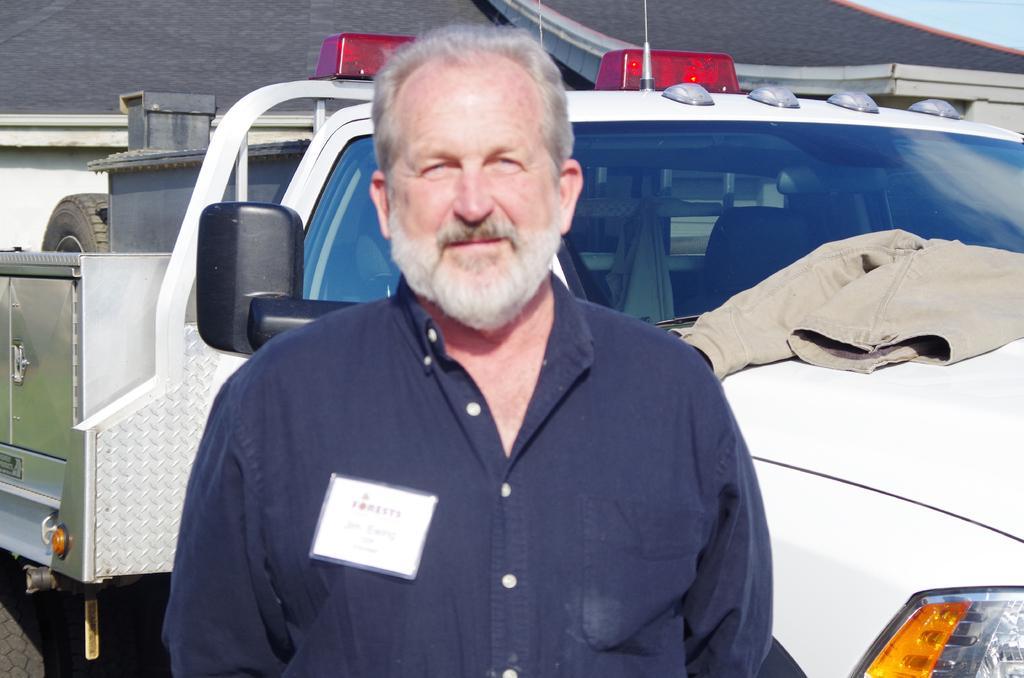Describe this image in one or two sentences. In this image there is a man, in the background there is a jeep and there is a house. 